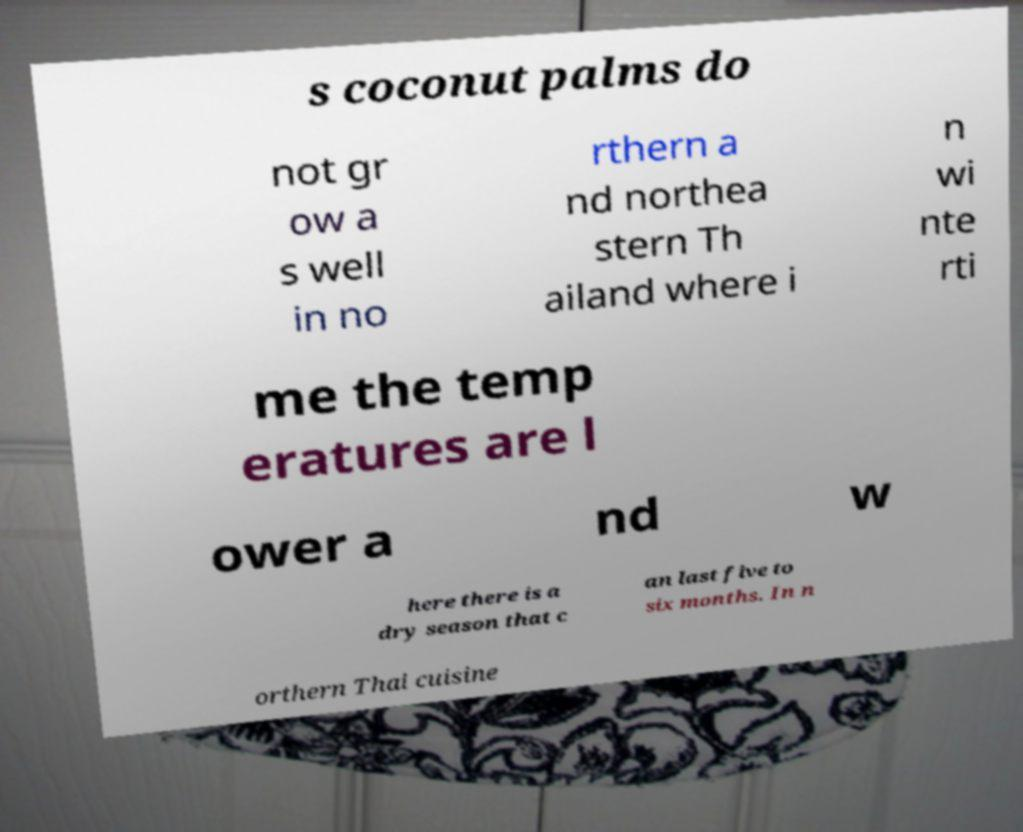What messages or text are displayed in this image? I need them in a readable, typed format. s coconut palms do not gr ow a s well in no rthern a nd northea stern Th ailand where i n wi nte rti me the temp eratures are l ower a nd w here there is a dry season that c an last five to six months. In n orthern Thai cuisine 